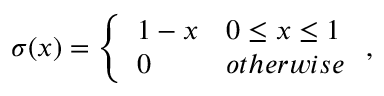<formula> <loc_0><loc_0><loc_500><loc_500>\sigma ( x ) = \left \{ \begin{array} { l l } { 1 - x } & { 0 \leq x \leq 1 } \\ { 0 } & { o t h e r w i s e } \end{array} ,</formula> 